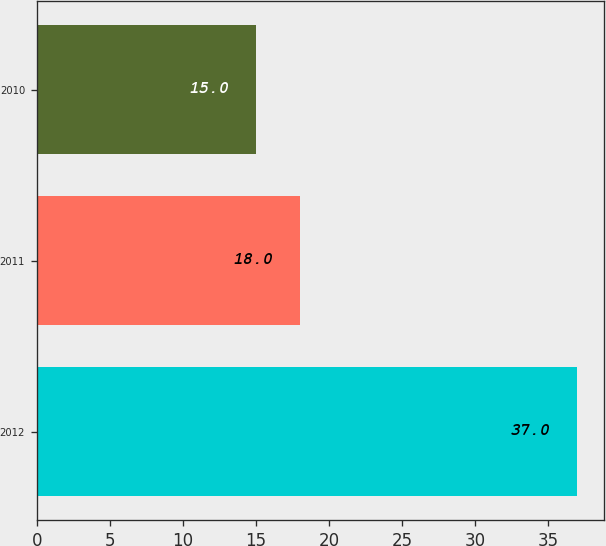Convert chart. <chart><loc_0><loc_0><loc_500><loc_500><bar_chart><fcel>2012<fcel>2011<fcel>2010<nl><fcel>37<fcel>18<fcel>15<nl></chart> 